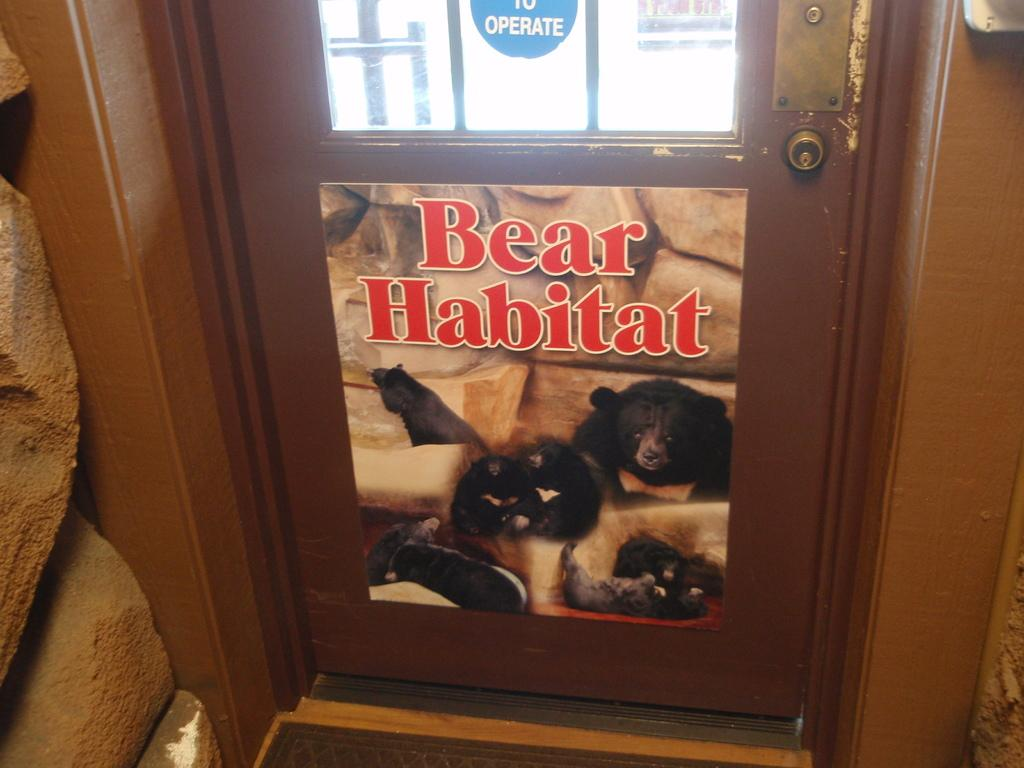What type of door is shown in the image? There is a brown color wooden door in the image. What is on the wooden door? There is text and a bear image on the wooden door. What else can be seen in the image besides the door? There are stones visible in the image. What type of birthday celebration is happening in the image? There is no indication of a birthday celebration in the image; it features a wooden door with a bear image and text. What time of day is depicted in the image? The time of day is not specified in the image; it only shows a wooden door with a bear image and text. 